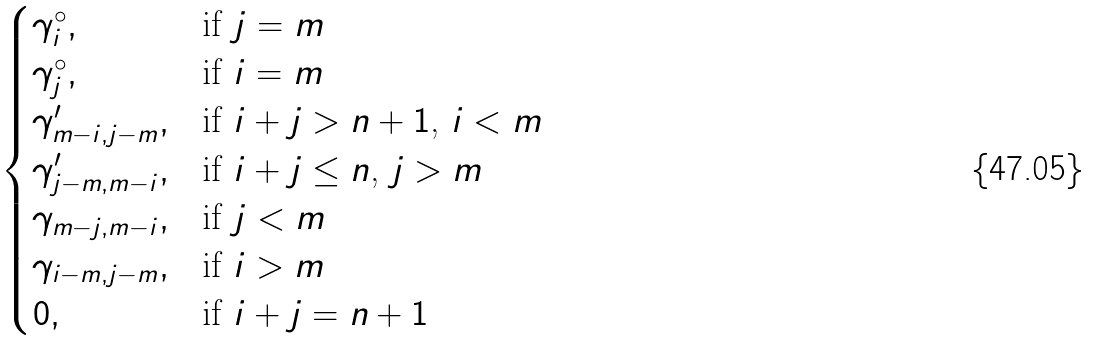Convert formula to latex. <formula><loc_0><loc_0><loc_500><loc_500>\begin{cases} \gamma ^ { \circ } _ { i } , & \text {if $j=m$} \\ \gamma ^ { \circ } _ { j } , & \text {if $i=m$} \\ \gamma ^ { \prime } _ { { m - i } , { j - m } } , & \text {if $i+j>n+1$, $i<m$} \\ \gamma ^ { \prime } _ { { j - m } , { m - i } } , & \text {if $i+j \leq n$, $j>m$} \\ \gamma _ { { m - j } , { m - i } } , & \text {if $j < m$} \\ \gamma _ { { i - m } , { j - m } } , & \text {if $i > m$} \\ 0 , & \text {if $i+j=n+1 $} \\ \end{cases}</formula> 